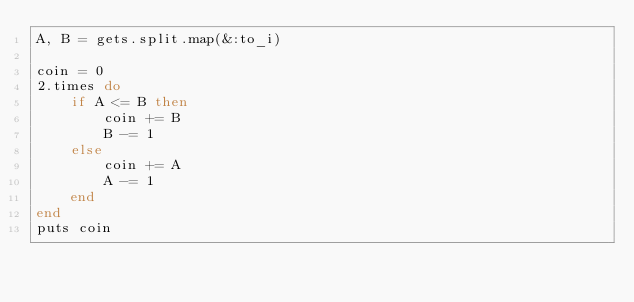<code> <loc_0><loc_0><loc_500><loc_500><_Ruby_>A, B = gets.split.map(&:to_i)

coin = 0
2.times do
    if A <= B then
        coin += B
        B -= 1
    else
        coin += A
        A -= 1
    end
end
puts coin</code> 